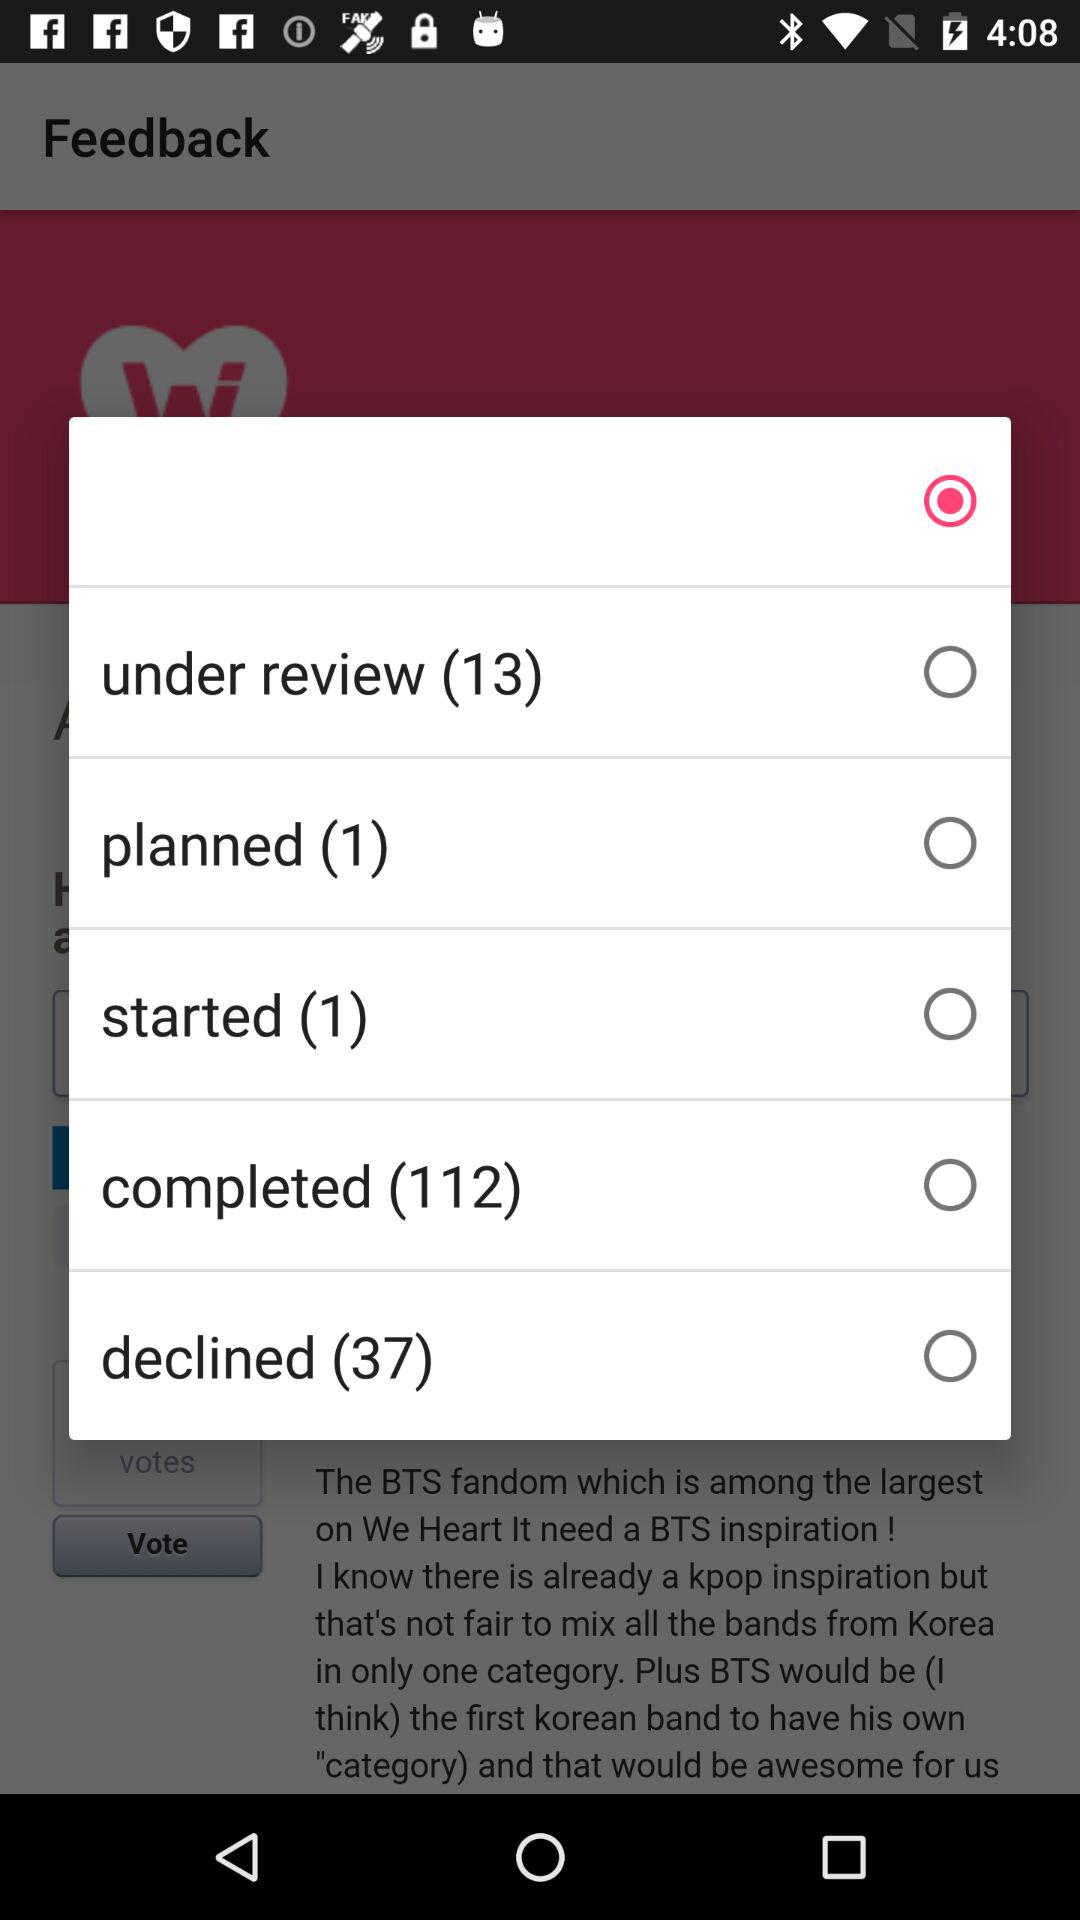How many more tasks are declined than started?
Answer the question using a single word or phrase. 36 